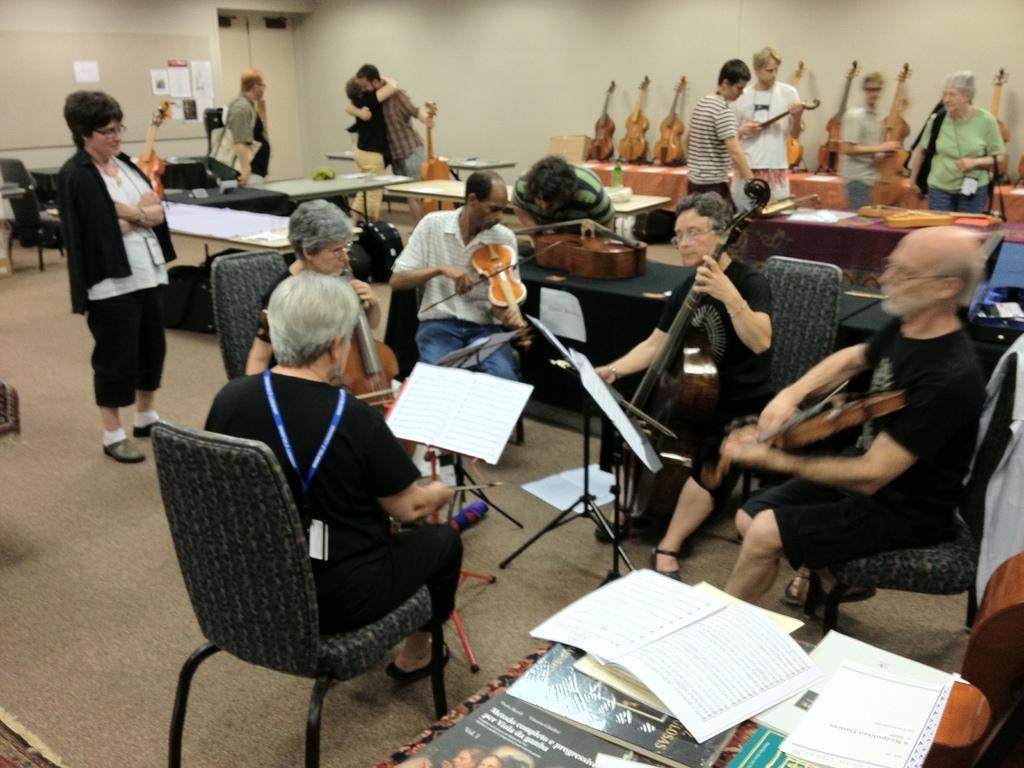How would you summarize this image in a sentence or two? This image is taken indoors. In the background there is a wall and there is a door. There are few papers stick on the wall. At the bottom of the image there is a table with many books on it. In the middle of the image there are many tables with many things on them. There are few empty chairs. There are many musical instruments on the tables. A few people are sitting on the chairs and playing music with musical instruments and a few are standing. 